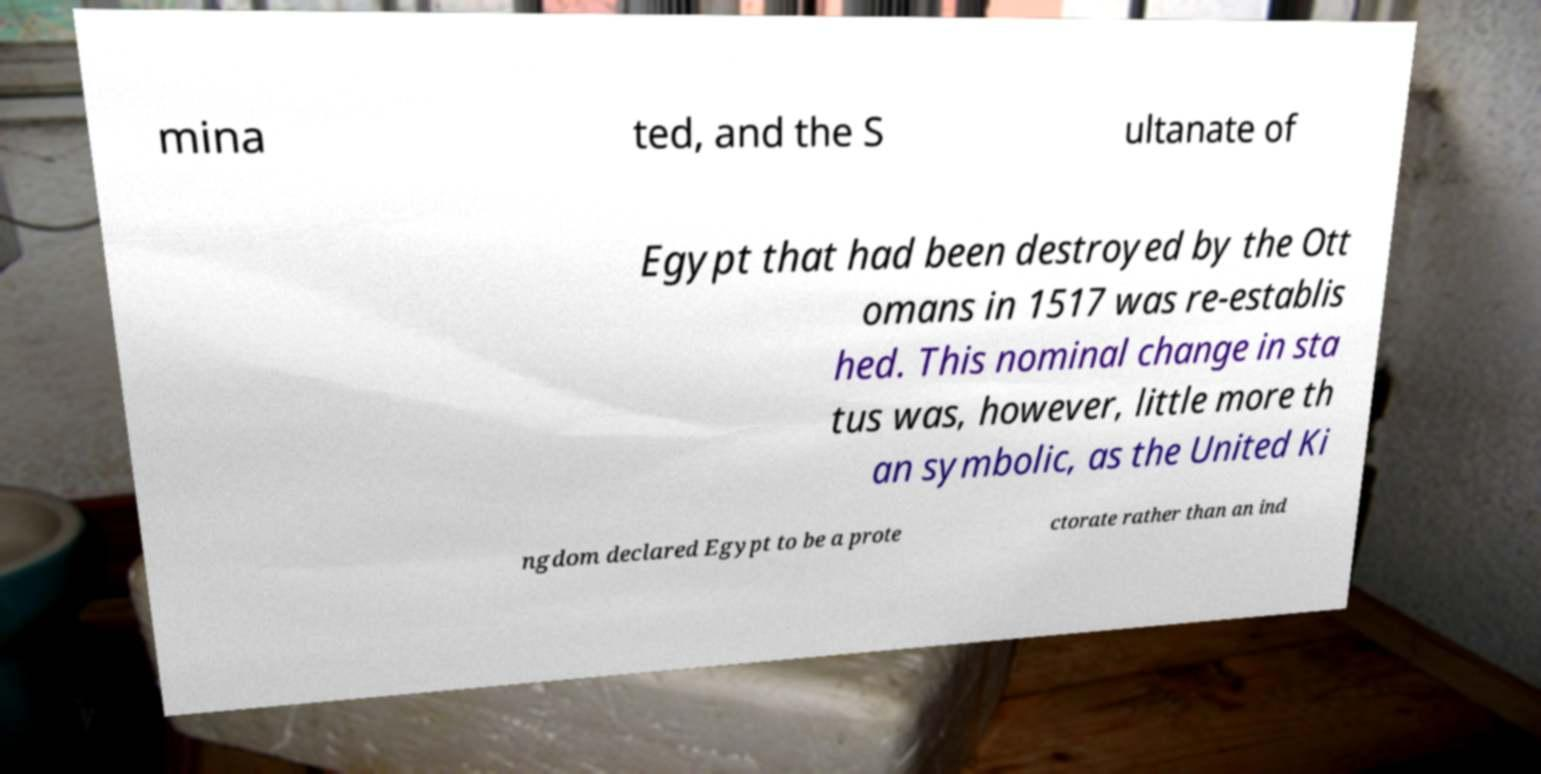Could you assist in decoding the text presented in this image and type it out clearly? mina ted, and the S ultanate of Egypt that had been destroyed by the Ott omans in 1517 was re-establis hed. This nominal change in sta tus was, however, little more th an symbolic, as the United Ki ngdom declared Egypt to be a prote ctorate rather than an ind 